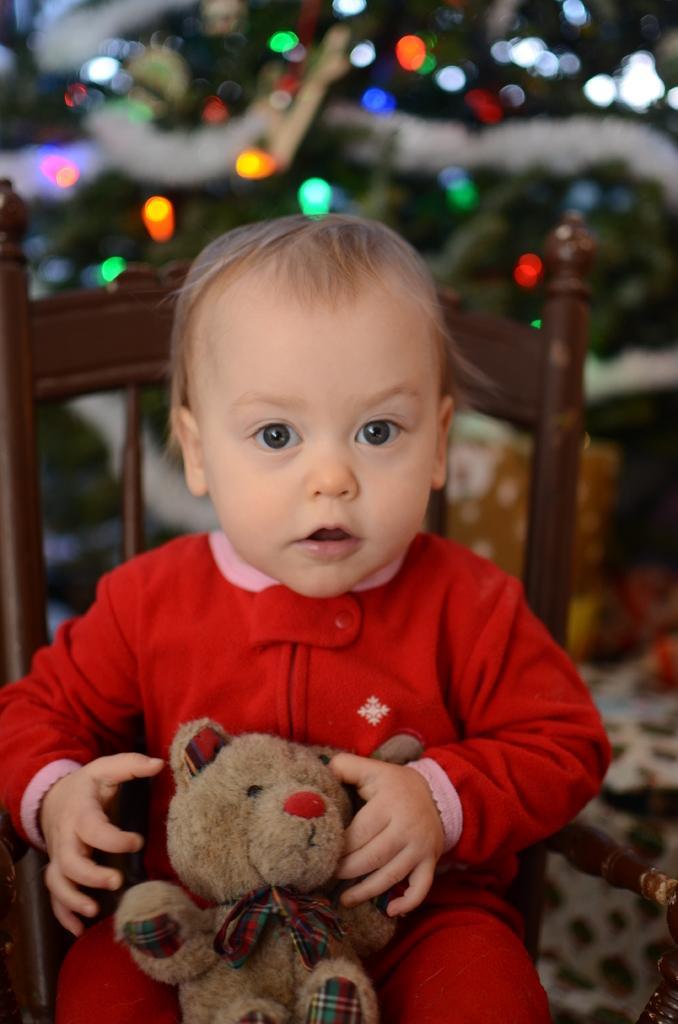Please provide a concise description of this image. In this image we can see a person sitting on a chair and the person is holding a toy. Behind the person we can see few lights. The background of the image is blurred. 